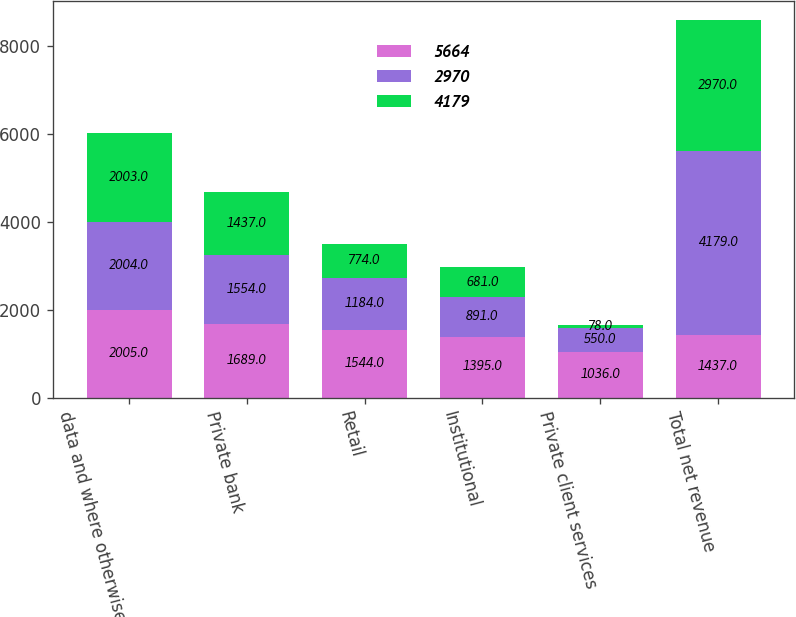Convert chart. <chart><loc_0><loc_0><loc_500><loc_500><stacked_bar_chart><ecel><fcel>data and where otherwise<fcel>Private bank<fcel>Retail<fcel>Institutional<fcel>Private client services<fcel>Total net revenue<nl><fcel>5664<fcel>2005<fcel>1689<fcel>1544<fcel>1395<fcel>1036<fcel>1437<nl><fcel>2970<fcel>2004<fcel>1554<fcel>1184<fcel>891<fcel>550<fcel>4179<nl><fcel>4179<fcel>2003<fcel>1437<fcel>774<fcel>681<fcel>78<fcel>2970<nl></chart> 